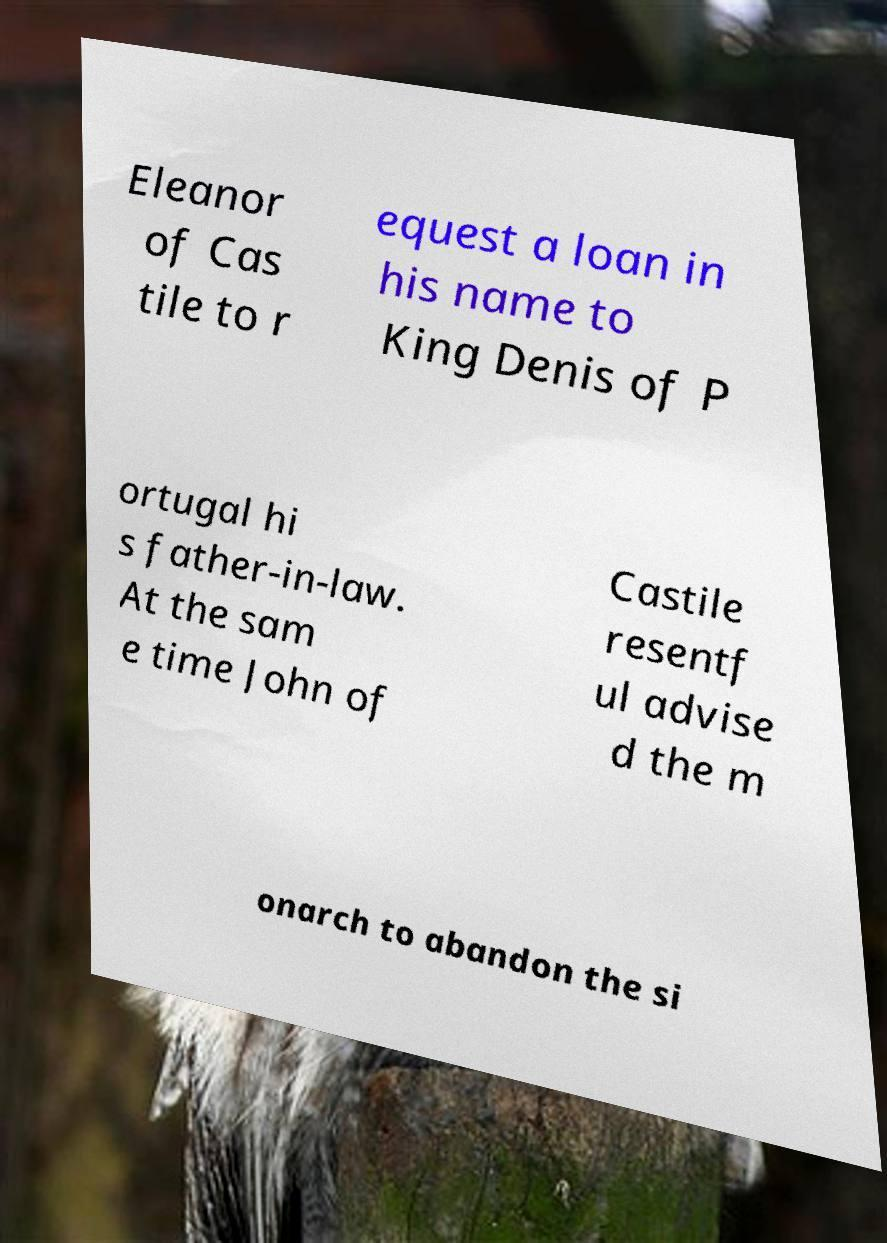For documentation purposes, I need the text within this image transcribed. Could you provide that? Eleanor of Cas tile to r equest a loan in his name to King Denis of P ortugal hi s father-in-law. At the sam e time John of Castile resentf ul advise d the m onarch to abandon the si 